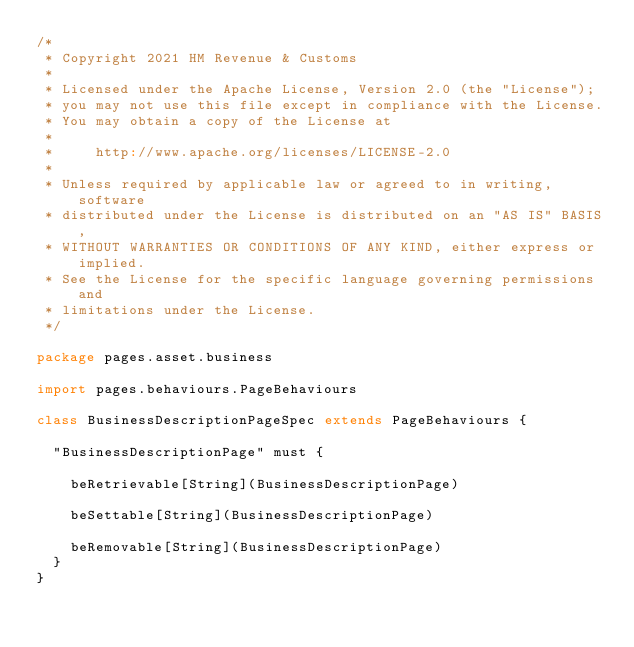Convert code to text. <code><loc_0><loc_0><loc_500><loc_500><_Scala_>/*
 * Copyright 2021 HM Revenue & Customs
 *
 * Licensed under the Apache License, Version 2.0 (the "License");
 * you may not use this file except in compliance with the License.
 * You may obtain a copy of the License at
 *
 *     http://www.apache.org/licenses/LICENSE-2.0
 *
 * Unless required by applicable law or agreed to in writing, software
 * distributed under the License is distributed on an "AS IS" BASIS,
 * WITHOUT WARRANTIES OR CONDITIONS OF ANY KIND, either express or implied.
 * See the License for the specific language governing permissions and
 * limitations under the License.
 */

package pages.asset.business

import pages.behaviours.PageBehaviours

class BusinessDescriptionPageSpec extends PageBehaviours {

  "BusinessDescriptionPage" must {

    beRetrievable[String](BusinessDescriptionPage)

    beSettable[String](BusinessDescriptionPage)

    beRemovable[String](BusinessDescriptionPage)
  }
}
</code> 